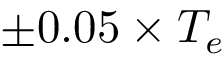<formula> <loc_0><loc_0><loc_500><loc_500>\pm 0 . 0 5 \times T _ { e }</formula> 